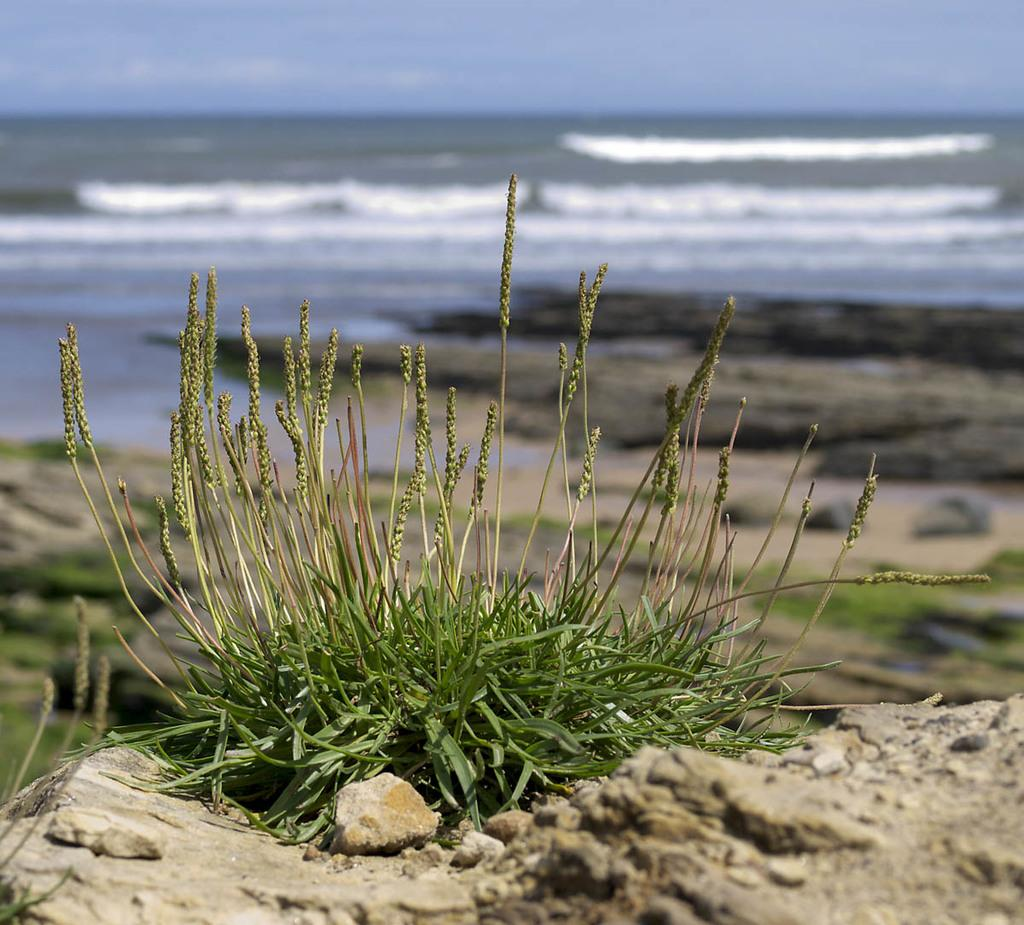What type of vegetation is present in the image? There is grass in the image. What can be seen in the distance in the image? There is water visible in the background of the image. How clear is the background of the image? The image may be slightly blurry in the background. How does the grass show respect to the tax collector in the image? There is no tax collector or any indication of respect in the image; it simply features grass and water in the background. 